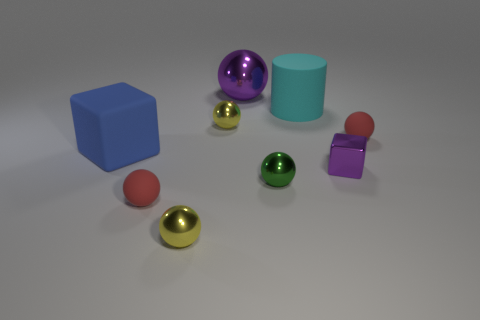Subtract 2 spheres. How many spheres are left? 4 Subtract all red spheres. How many spheres are left? 4 Subtract all large shiny spheres. How many spheres are left? 5 Subtract all purple balls. Subtract all blue blocks. How many balls are left? 5 Add 1 tiny purple things. How many objects exist? 10 Subtract all cylinders. How many objects are left? 8 Add 7 tiny purple shiny cubes. How many tiny purple shiny cubes are left? 8 Add 5 large yellow shiny blocks. How many large yellow shiny blocks exist? 5 Subtract 1 blue cubes. How many objects are left? 8 Subtract all large yellow shiny cubes. Subtract all red rubber balls. How many objects are left? 7 